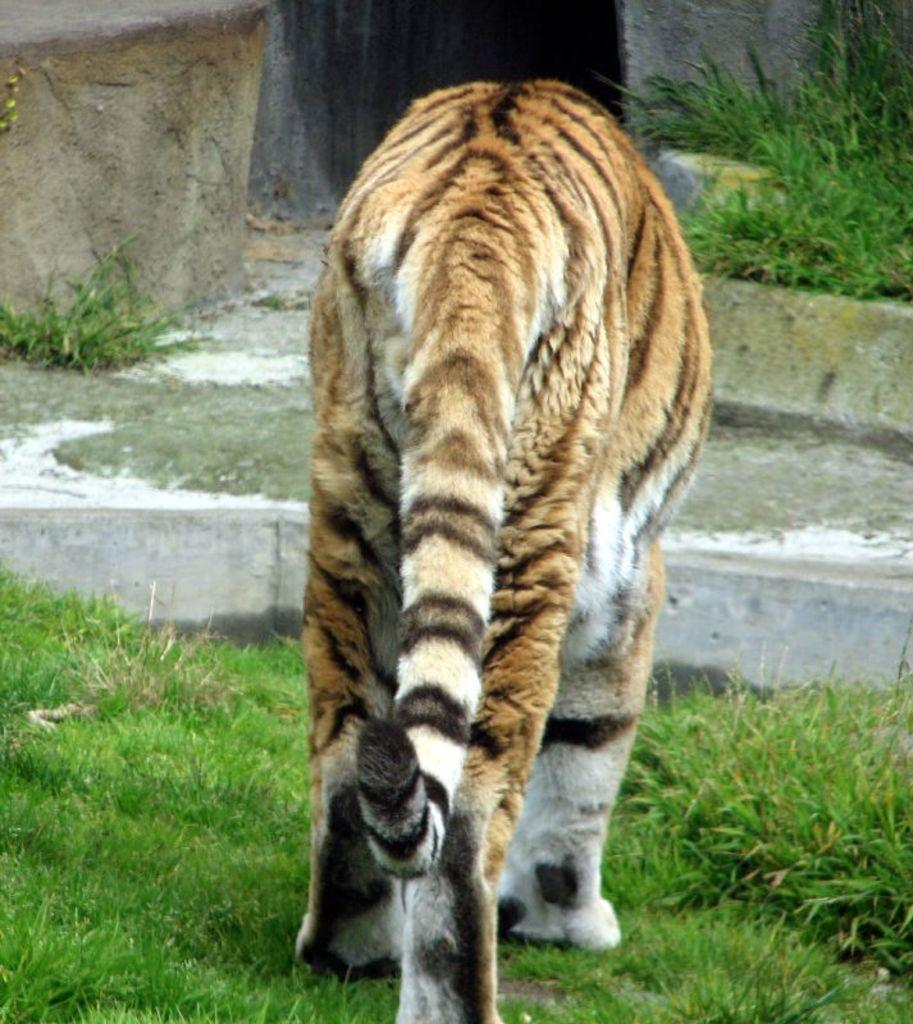What animal is in the image? There is a tiger in the image. What is the tiger standing on? The tiger is standing on the grass. What type of scarf is the tiger wearing in the image? There is no scarf present in the image; the tiger is not wearing any clothing. 